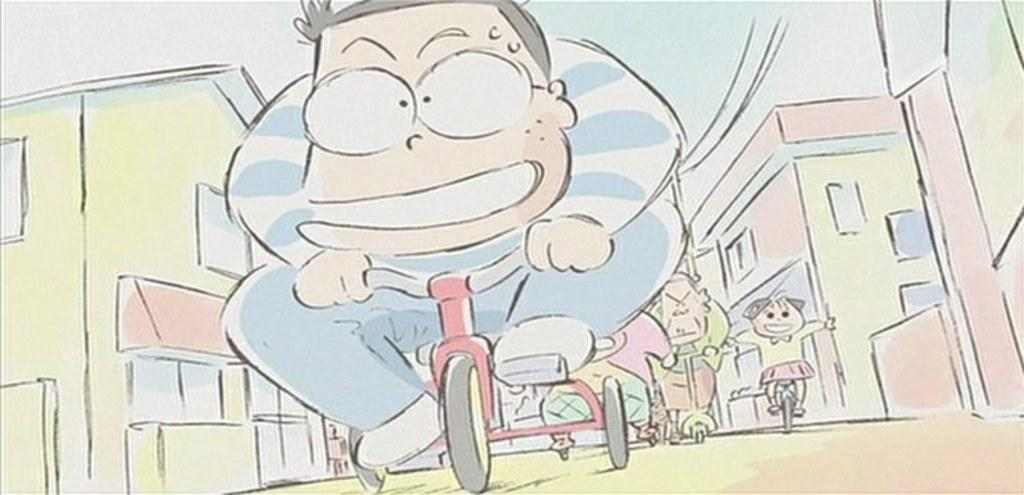What is the main subject of the drawing in the image? The drawing depicts two kids and an old woman. What is the old woman doing in the drawing? The old woman is riding a bike in the drawing. Where is the bike located in the drawing? The bike is on a road in the drawing. What can be seen on either side of the road in the drawing? There are buildings on either side of the road in the drawing. What type of pen is used to draw the buildings in the image? There is no pen visible in the image, as it is a drawing and not an actual photograph. 